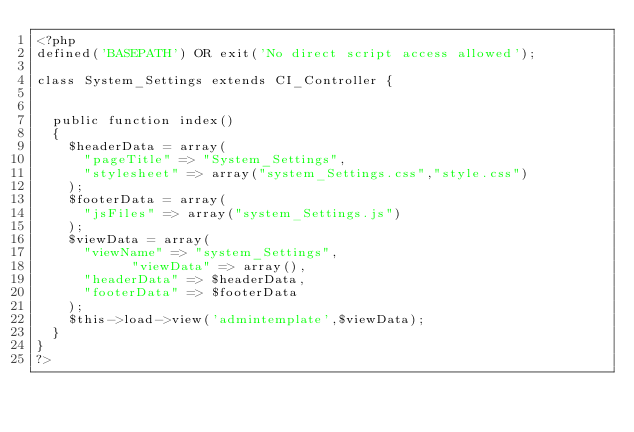<code> <loc_0><loc_0><loc_500><loc_500><_PHP_><?php
defined('BASEPATH') OR exit('No direct script access allowed');

class System_Settings extends CI_Controller {


	public function index()
	{		
		$headerData = array(
			"pageTitle" => "System_Settings",
			"stylesheet" => array("system_Settings.css","style.css")
		);
		$footerData = array(
			"jsFiles" => array("system_Settings.js")
		);
		$viewData = array(
			"viewName" => "system_Settings",
            "viewData" => array(),
			"headerData" => $headerData,
			"footerData" => $footerData	
		);
		$this->load->view('admintemplate',$viewData);
	}
}
?></code> 